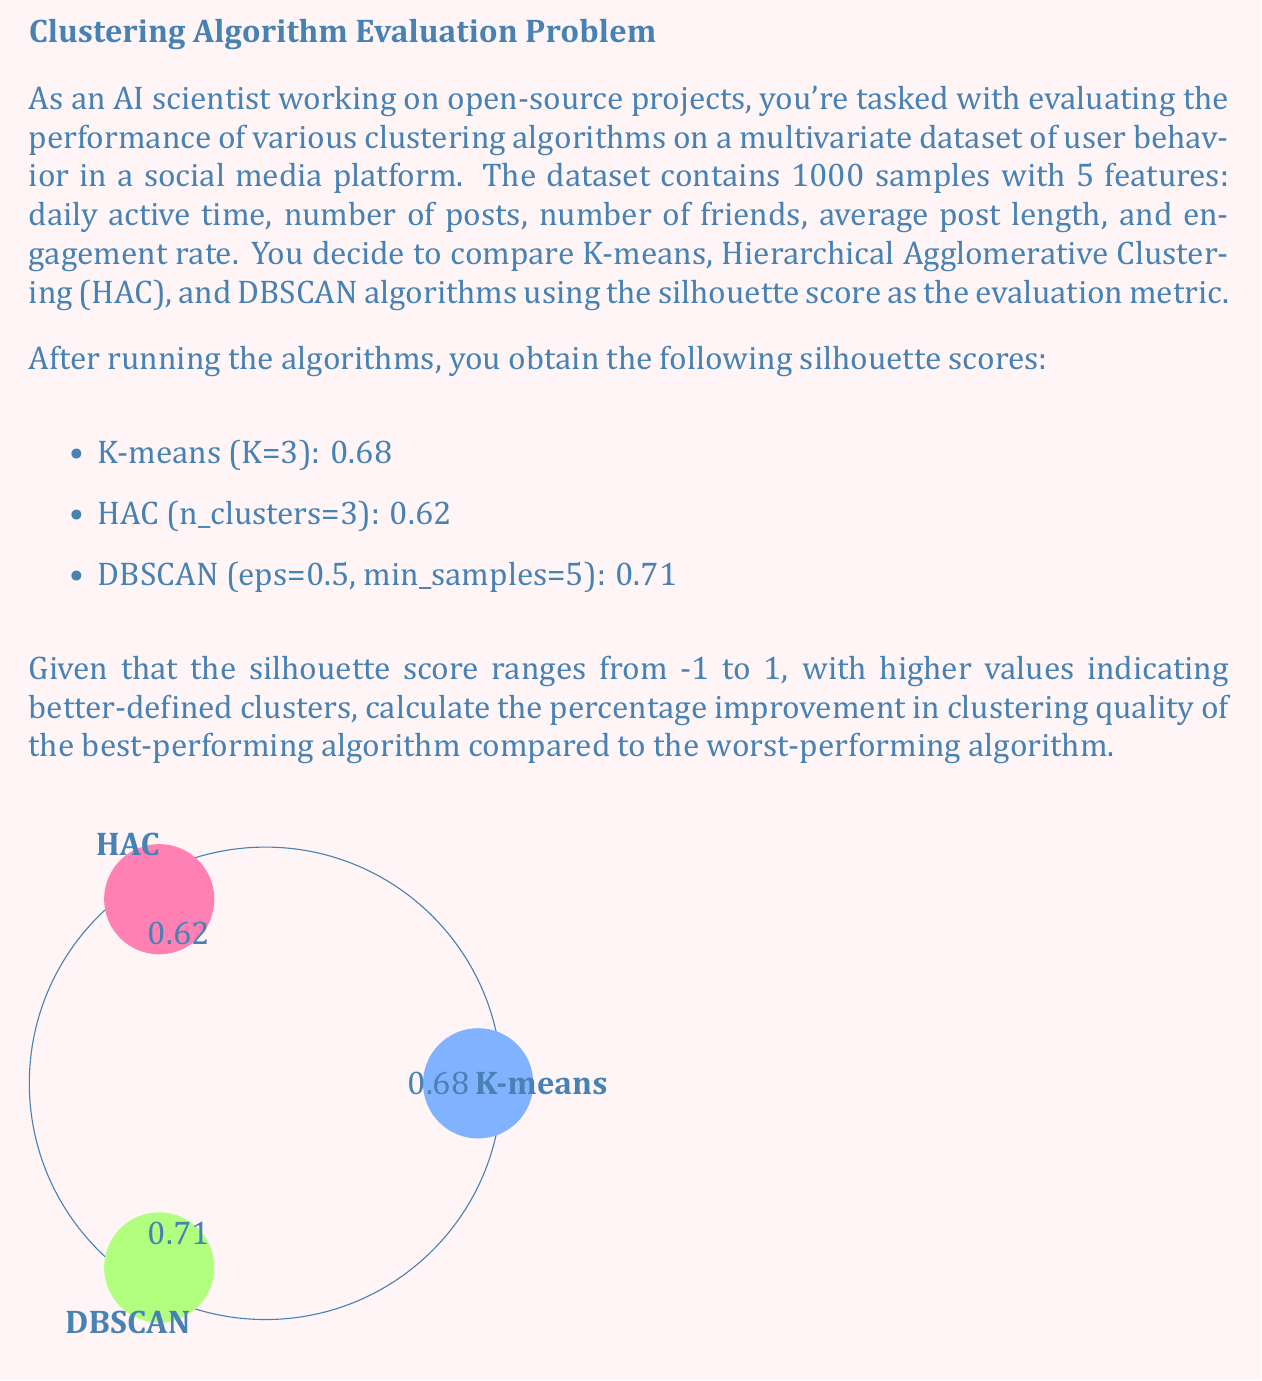Can you solve this math problem? To solve this problem, we'll follow these steps:

1. Identify the best and worst performing algorithms based on the silhouette scores.
2. Calculate the difference between the best and worst scores.
3. Compute the percentage improvement using the formula:
   $$\text{Percentage Improvement} = \frac{\text{Best Score} - \text{Worst Score}}{\text{Worst Score}} \times 100\%$$

Step 1: Identifying best and worst algorithms
Best performing: DBSCAN with a score of 0.71
Worst performing: HAC with a score of 0.62

Step 2: Calculating the difference
Difference = 0.71 - 0.62 = 0.09

Step 3: Computing the percentage improvement
$$\begin{align*}
\text{Percentage Improvement} &= \frac{0.71 - 0.62}{0.62} \times 100\% \\
&= \frac{0.09}{0.62} \times 100\% \\
&= 0.1451612903 \times 100\% \\
&\approx 14.52\%
\end{align*}$$

Therefore, the percentage improvement in clustering quality of the best-performing algorithm (DBSCAN) compared to the worst-performing algorithm (HAC) is approximately 14.52%.
Answer: 14.52% 